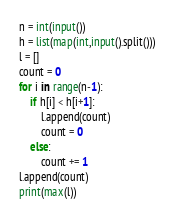Convert code to text. <code><loc_0><loc_0><loc_500><loc_500><_Python_>n = int(input())
h = list(map(int,input().split()))
l = []
count = 0
for i in range(n-1):
    if h[i] < h[i+1]:
        l.append(count)
        count = 0
    else:
        count += 1
l.append(count)
print(max(l))</code> 